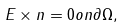<formula> <loc_0><loc_0><loc_500><loc_500>E \times n = 0 o n \partial \Omega ,</formula> 